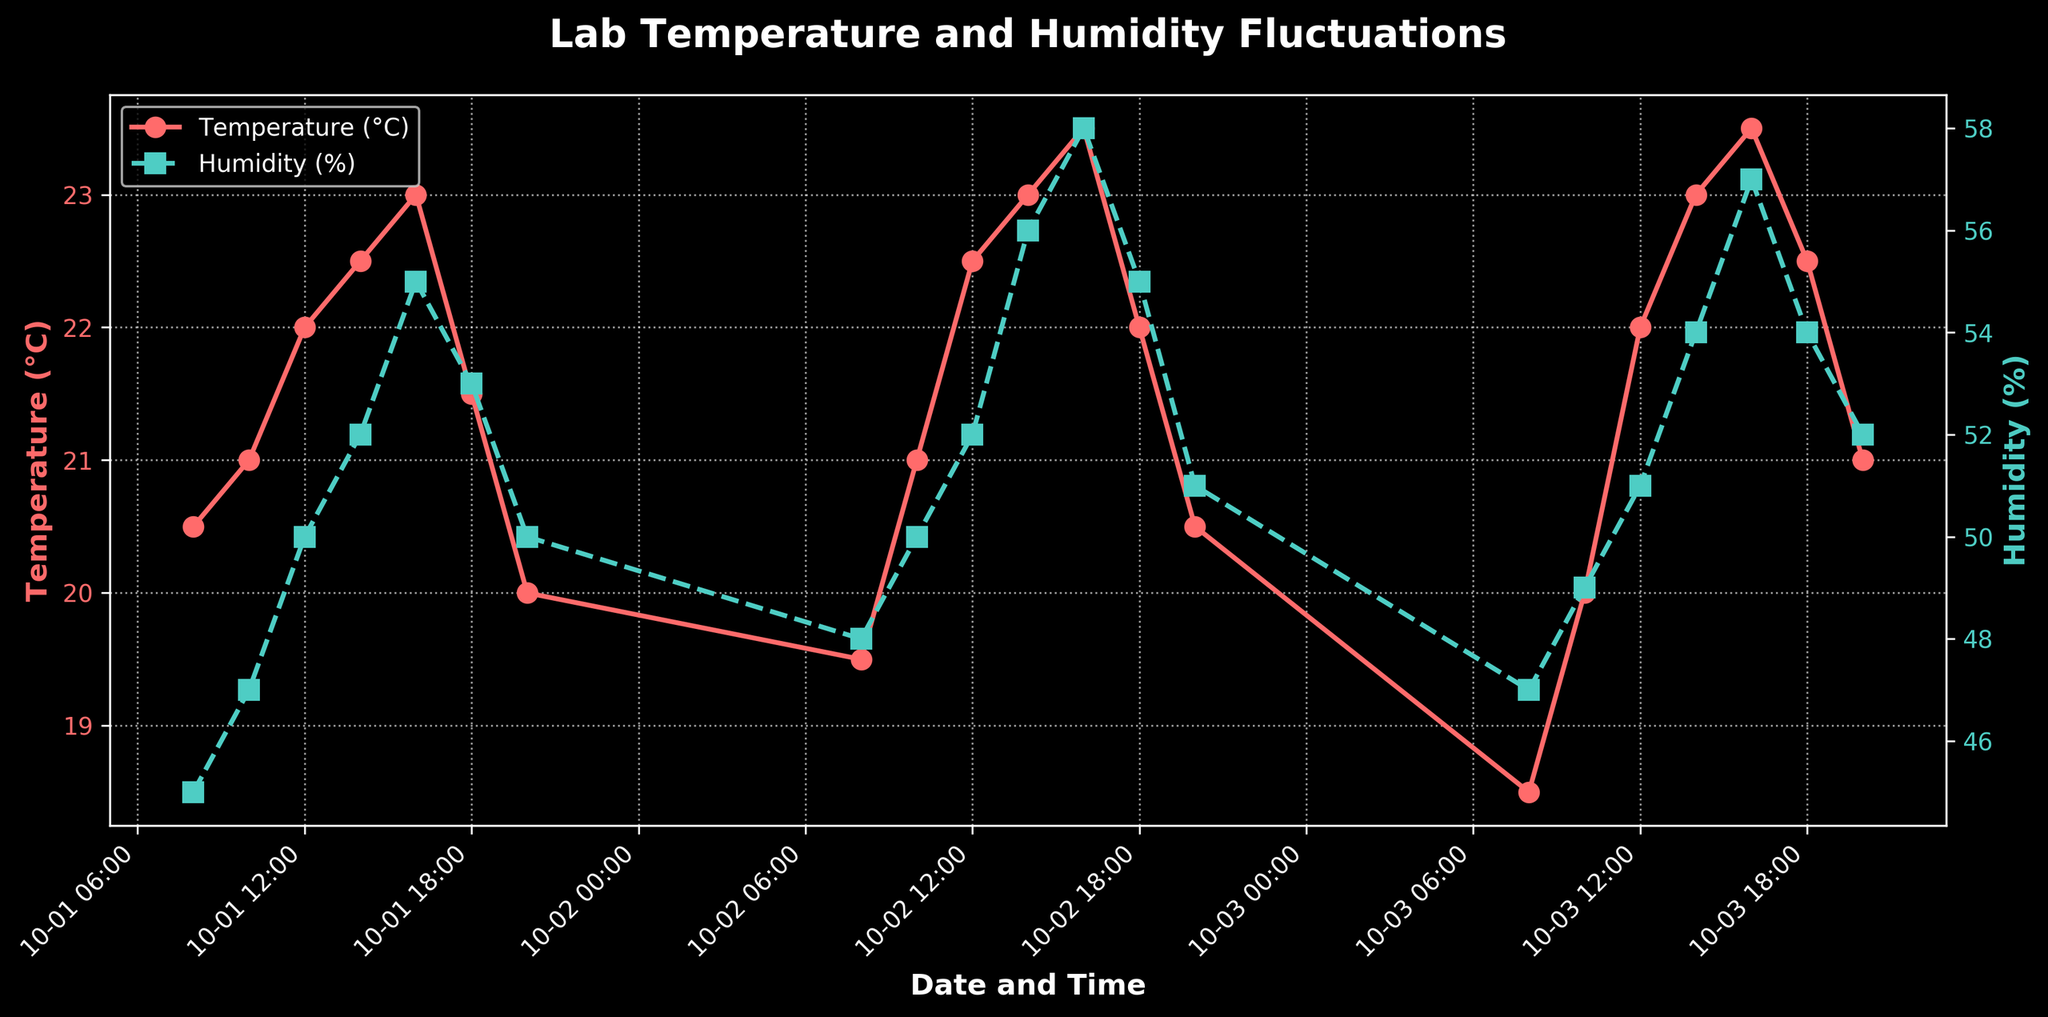What is the title of the plot? The title of the plot is written at the top of the figure. It reads "Lab Temperature and Humidity Fluctuations".
Answer: Lab Temperature and Humidity Fluctuations How does the temperature change on October 1 between 8:00 and 20:00? On October 1, the temperature starts at 20.5°C at 08:00 and increases, peaking at 23.0°C by 16:00. It then decreases to 20.0°C by 20:00.
Answer: Starts at 20.5°C, peaks at 23.0°C, then decreases to 20.0°C What is the highest recorded humidity percentage in the time series? The highest humidity percentage can be found by looking at the peak of the green line, which is 58% on October 2 at 16:00.
Answer: 58% What is the average temperature at 16:00 over the three days? On each day, the temperature at 16:00 is 23.0°C (October 1), 23.5°C (October 2), and 23.5°C (October 3). The average is calculated as (23.0 + 23.5 + 23.5) / 3.
Answer: 23.33°C Compare the humidity at 12:00 and 18:00 on each day. What differences or similarities do you notice? On October 1: 50% (12:00) and 53% (18:00); October 2: 52% (12:00) and 55% (18:00); October 3: 51% (12:00) and 54% (18:00). The humidity increases from 12:00 to 18:00 on each day.
Answer: Humidity increases from 12:00 to 18:00 each day During which time period is the temperature relatively stable between October 1 and October 3? The temperature appears relatively stable during the night and early morning hours, specifically from 20:00 to 08:00, with variations ranging from 20.0°C to 19.5°C and 19.5°C to 18.5°C.
Answer: 20:00 to 08:00 When does the temperature reach its peak value and what is that value? The temperature peaks at 23.5°C on both October 2 at 16:00 and October 3 at 16:00.
Answer: 23.5°C on October 2 and October 3 at 16:00 How do the fluctuations in humidity correlate with the temperature changes over the days? Generally, as the temperature peaks in the afternoon, the humidity also shows a peak, indicating a positive correlation between temperature and humidity fluctuations.
Answer: Positive correlation between temperature and humidity What is the overall trend in temperature from October 1 to October 3? The temperature shows a general increase from morning to afternoon each day, followed by a decline in the evening, but overall, it gradually increases from October 1 to October 3.
Answer: Gradually increasing trend 